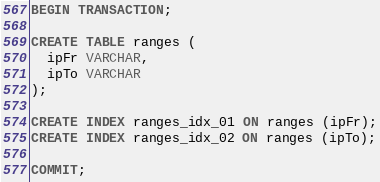<code> <loc_0><loc_0><loc_500><loc_500><_SQL_>BEGIN TRANSACTION;

CREATE TABLE ranges (
  ipFr VARCHAR,
  ipTo VARCHAR
);

CREATE INDEX ranges_idx_01 ON ranges (ipFr);
CREATE INDEX ranges_idx_02 ON ranges (ipTo);

COMMIT;
</code> 